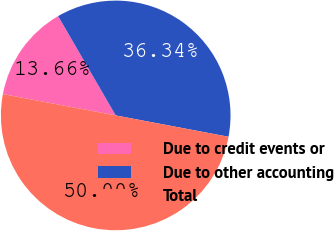Convert chart to OTSL. <chart><loc_0><loc_0><loc_500><loc_500><pie_chart><fcel>Due to credit events or<fcel>Due to other accounting<fcel>Total<nl><fcel>13.66%<fcel>36.34%<fcel>50.0%<nl></chart> 